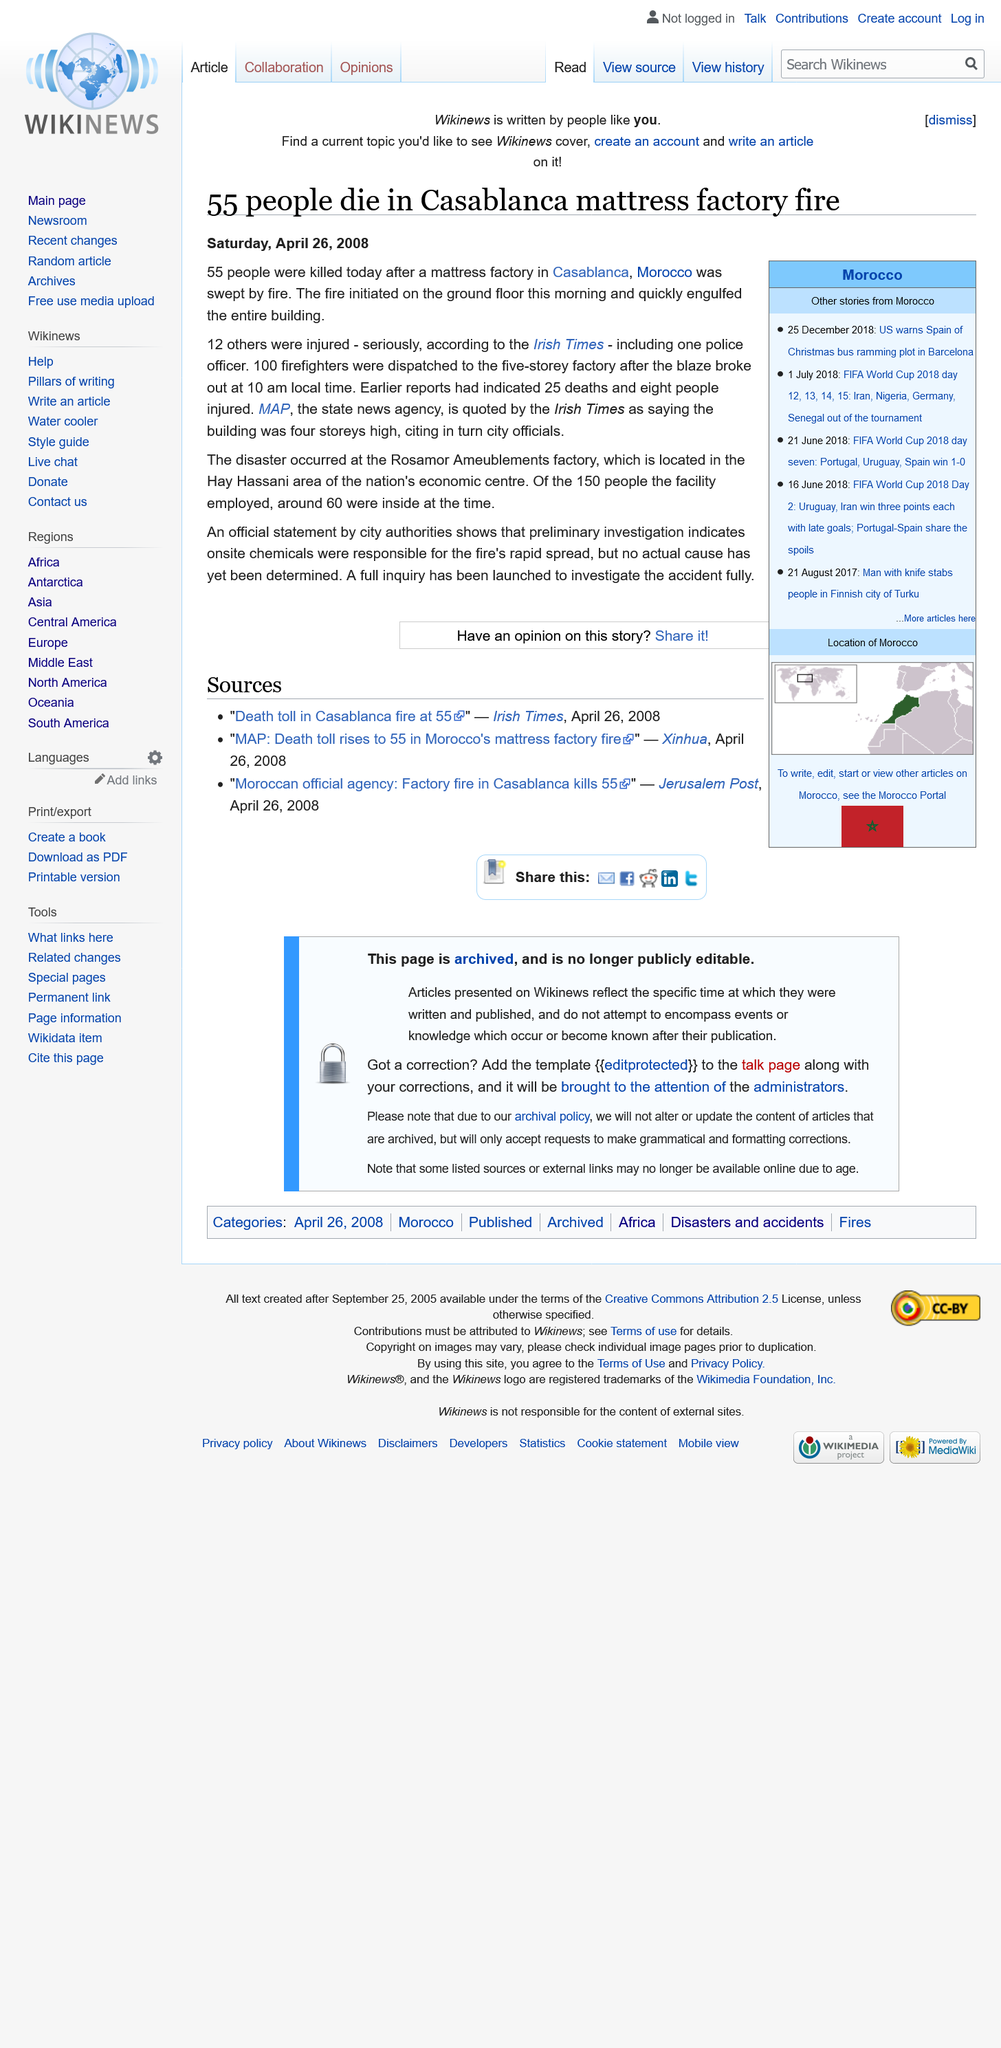Draw attention to some important aspects in this diagram. A total of 55 people were killed at the mattress factory. According to the Irish Times, 12 people were injured. A total of 100 firefighters were dispatched. 